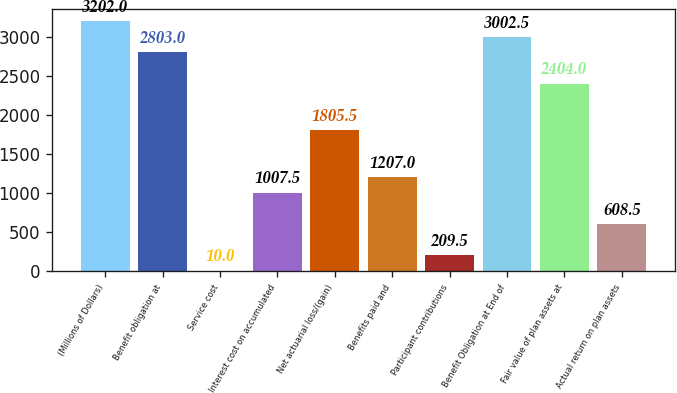Convert chart to OTSL. <chart><loc_0><loc_0><loc_500><loc_500><bar_chart><fcel>(Millions of Dollars)<fcel>Benefit obligation at<fcel>Service cost<fcel>Interest cost on accumulated<fcel>Net actuarial loss/(gain)<fcel>Benefits paid and<fcel>Participant contributions<fcel>Benefit Obligation at End of<fcel>Fair value of plan assets at<fcel>Actual return on plan assets<nl><fcel>3202<fcel>2803<fcel>10<fcel>1007.5<fcel>1805.5<fcel>1207<fcel>209.5<fcel>3002.5<fcel>2404<fcel>608.5<nl></chart> 